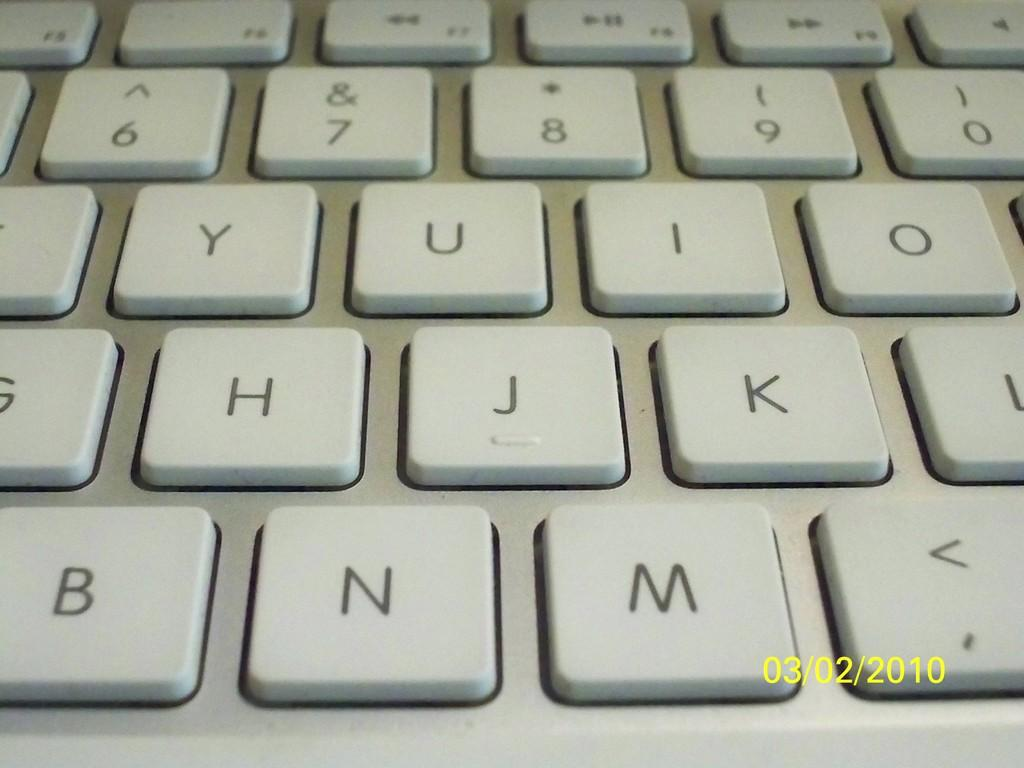<image>
Render a clear and concise summary of the photo. A keyboard with keys like N and M. 